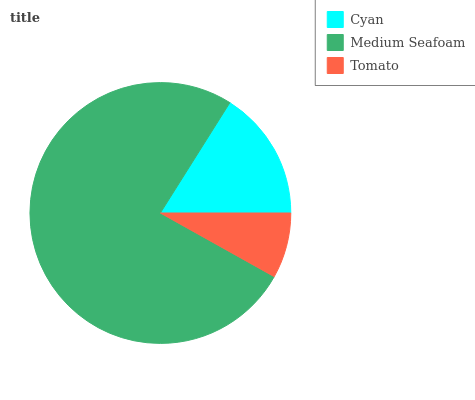Is Tomato the minimum?
Answer yes or no. Yes. Is Medium Seafoam the maximum?
Answer yes or no. Yes. Is Medium Seafoam the minimum?
Answer yes or no. No. Is Tomato the maximum?
Answer yes or no. No. Is Medium Seafoam greater than Tomato?
Answer yes or no. Yes. Is Tomato less than Medium Seafoam?
Answer yes or no. Yes. Is Tomato greater than Medium Seafoam?
Answer yes or no. No. Is Medium Seafoam less than Tomato?
Answer yes or no. No. Is Cyan the high median?
Answer yes or no. Yes. Is Cyan the low median?
Answer yes or no. Yes. Is Tomato the high median?
Answer yes or no. No. Is Tomato the low median?
Answer yes or no. No. 